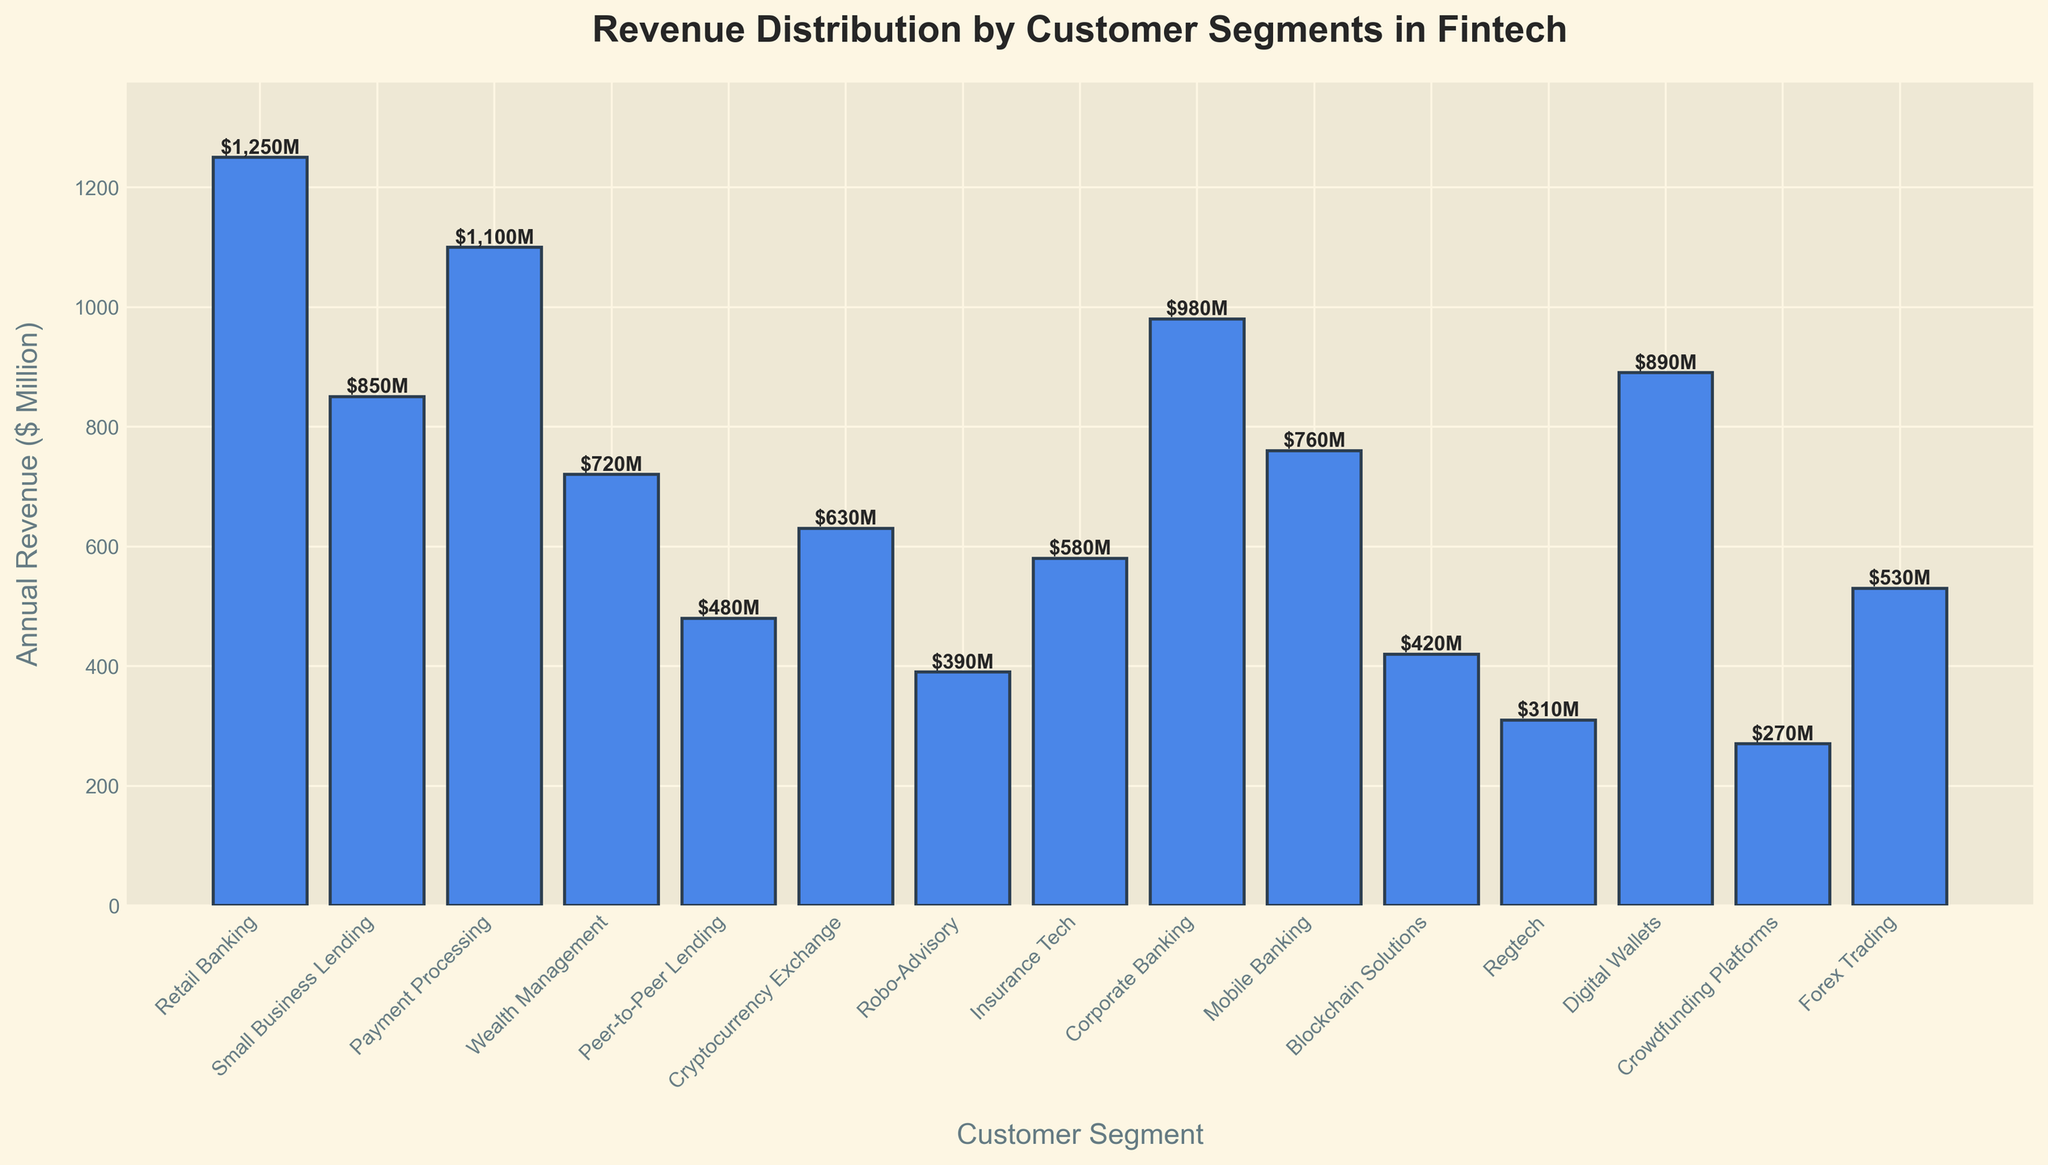Which customer segment has the highest annual revenue? To find the customer segment with the highest annual revenue, we look for the tallest bar in the chart. The Retail Banking segment's bar reaches the highest point.
Answer: Retail Banking What is the difference in annual revenue between Wealth Management and Small Business Lending? First, identify the heights of the bars for Wealth Management ($720M) and Small Business Lending ($850M). Then, calculate the difference: $850M - $720M = $130M.
Answer: $130M How much total revenue is generated by Peer-to-Peer Lending, Cryptocurrency Exchange, and Blockchain Solutions combined? Identify the individual revenues: Peer-to-Peer Lending ($480M), Cryptocurrency Exchange ($630M), and Blockchain Solutions ($420M). Then, add these values: $480M + $630M + $420M = $1,530M.
Answer: $1,530M Which segment generates less revenue than Mobile Banking but more revenue than Crowdfunding Platforms? Look at the chart to find the revenue for Mobile Banking ($760M) and Crowdfunding Platforms ($270M). Identify bars within this range. The Insurance Tech bar at $580M fits this criterion.
Answer: Insurance Tech Rank the top three customer segments by revenue. Identify the segments with the top three tallest bars: 1) Retail Banking ($1250M), 2) Payment Processing ($1100M), and 3) Corporate Banking ($980M).
Answer: Retail Banking, Payment Processing, Corporate Banking Compare the revenues of Robo-Advisory and Forex Trading. Which one is greater and by how much? Identify the revenues for Robo-Advisory ($390M) and Forex Trading ($530M). Calculate the difference: $530M - $390M = $140M. Forex Trading has a higher revenue by $140M.
Answer: Forex Trading by $140M What is the average revenue of Digital Wallets and Payment Processing? Identify the revenues: Digital Wallets ($890M) and Payment Processing ($1100M). Calculate the average: ($890M + $1100M) / 2 = $995M.
Answer: $995M Which customer segments have an annual revenue of less than $500M? Identify bars with heights representing less than $500M: Peer-to-Peer Lending ($480M), Robo-Advisory ($390M), Blockchain Solutions ($420M), Regtech ($310M), and Crowdfunding Platforms ($270M).
Answer: Peer-to-Peer Lending, Robo-Advisory, Blockchain Solutions, Regtech, Crowdfunding Platforms What is the sum of the annual revenue from Retail Banking, Corporate Banking, and Small Business Lending? Identify the revenues: Retail Banking ($1250M), Corporate Banking ($980M), and Small Business Lending ($850M). Calculate the sum: $1250M + $980M + $850M = $3080M.
Answer: $3080M 